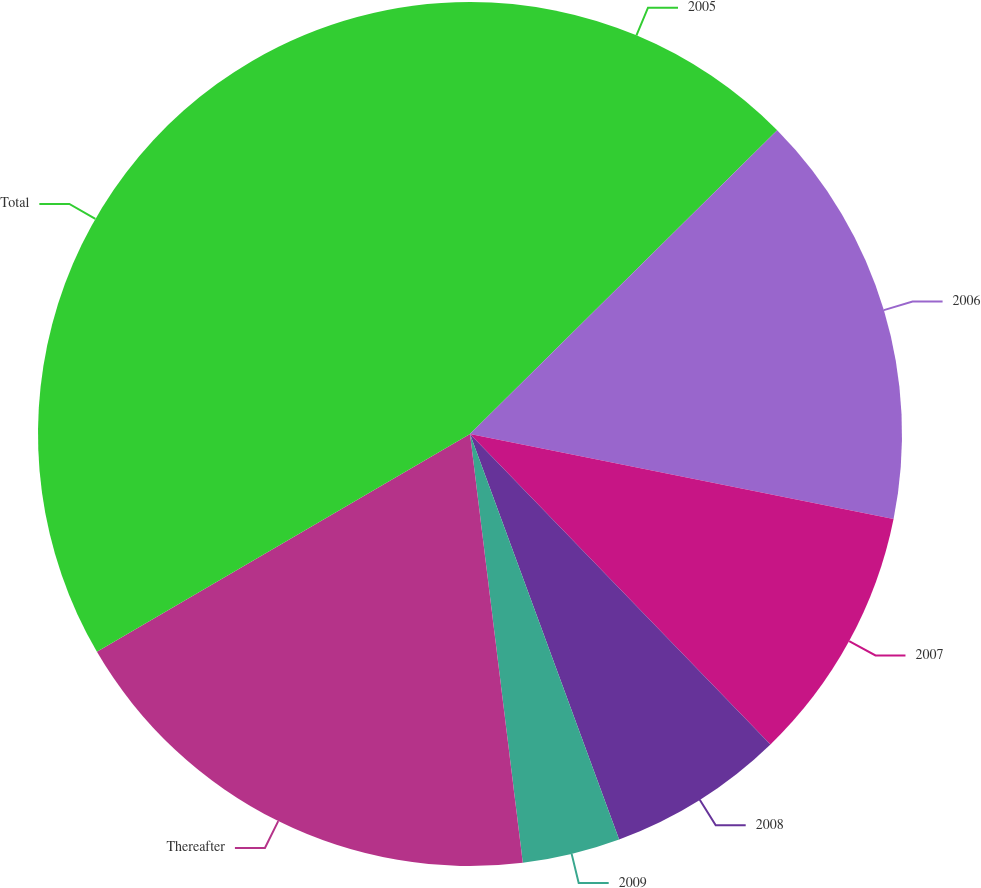Convert chart to OTSL. <chart><loc_0><loc_0><loc_500><loc_500><pie_chart><fcel>2005<fcel>2006<fcel>2007<fcel>2008<fcel>2009<fcel>Thereafter<fcel>Total<nl><fcel>12.59%<fcel>15.56%<fcel>9.61%<fcel>6.63%<fcel>3.66%<fcel>18.54%<fcel>33.41%<nl></chart> 